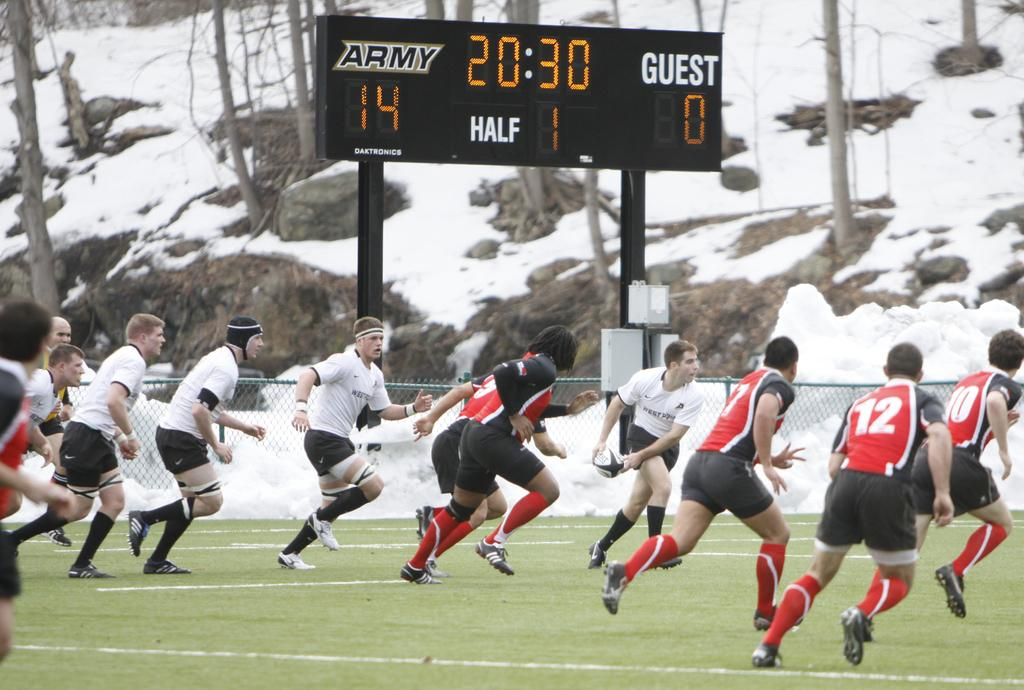What are the people in the image doing? The people in the image are running. What object is present in the image that is commonly used in sports? There is a ball in the image. What can be seen in the background of the image that indicates the location or setting? There is a scoreboard and snow visible in the background of the image. What type of natural environment is visible in the background of the image? There are trees in the background of the image. What type of yam is being used as a prop in the image? There is no yam present in the image; it features people running with a ball in the background of a snowy area with trees and a scoreboard. How does the street factor into the image? There is no street visible in the image; it takes place in a snowy area with trees and a scoreboard in the background. 